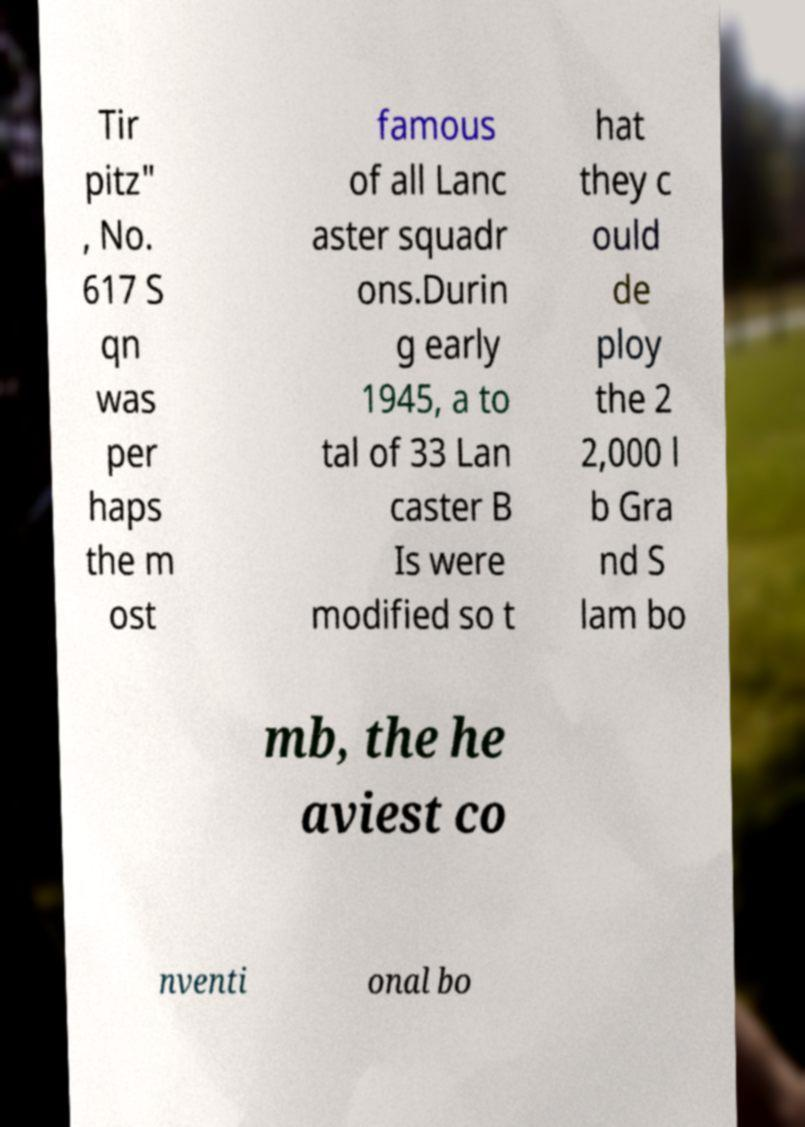Please read and relay the text visible in this image. What does it say? Tir pitz" , No. 617 S qn was per haps the m ost famous of all Lanc aster squadr ons.Durin g early 1945, a to tal of 33 Lan caster B Is were modified so t hat they c ould de ploy the 2 2,000 l b Gra nd S lam bo mb, the he aviest co nventi onal bo 